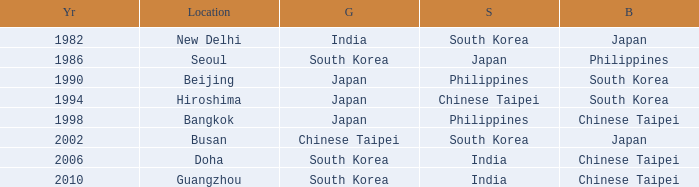Which Bronze has a Year smaller than 1994, and a Silver of south korea? Japan. 